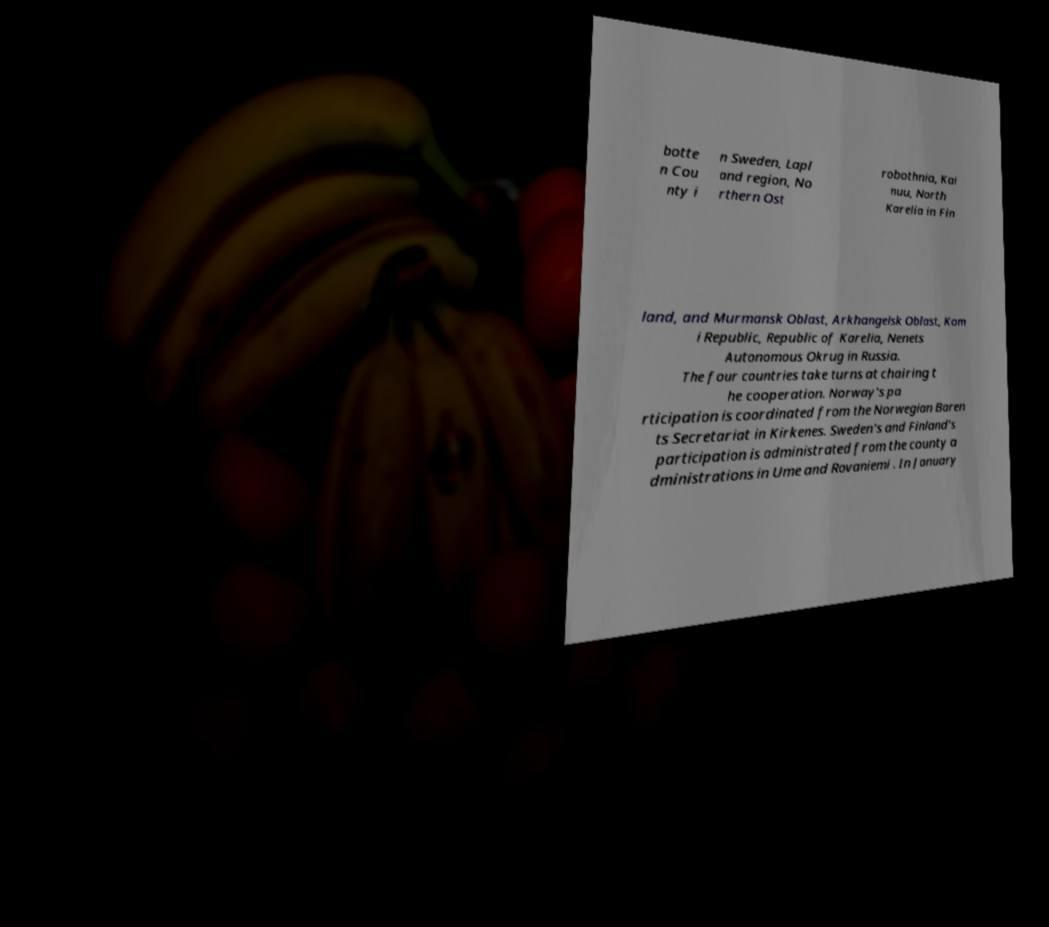What messages or text are displayed in this image? I need them in a readable, typed format. botte n Cou nty i n Sweden, Lapl and region, No rthern Ost robothnia, Kai nuu, North Karelia in Fin land, and Murmansk Oblast, Arkhangelsk Oblast, Kom i Republic, Republic of Karelia, Nenets Autonomous Okrug in Russia. The four countries take turns at chairing t he cooperation. Norway's pa rticipation is coordinated from the Norwegian Baren ts Secretariat in Kirkenes. Sweden's and Finland's participation is administrated from the county a dministrations in Ume and Rovaniemi . In January 